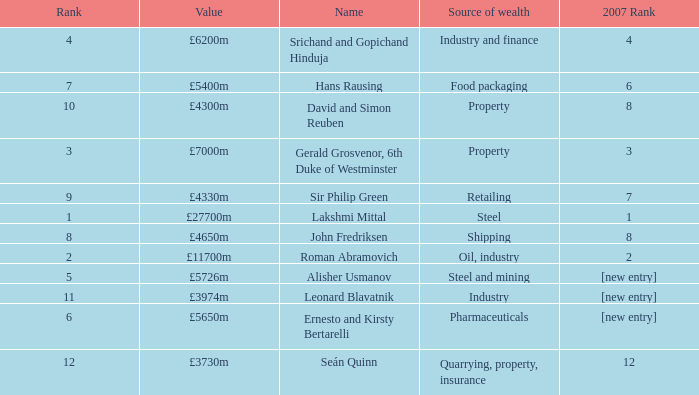What source of wealth has a value of £5726m? Steel and mining. 